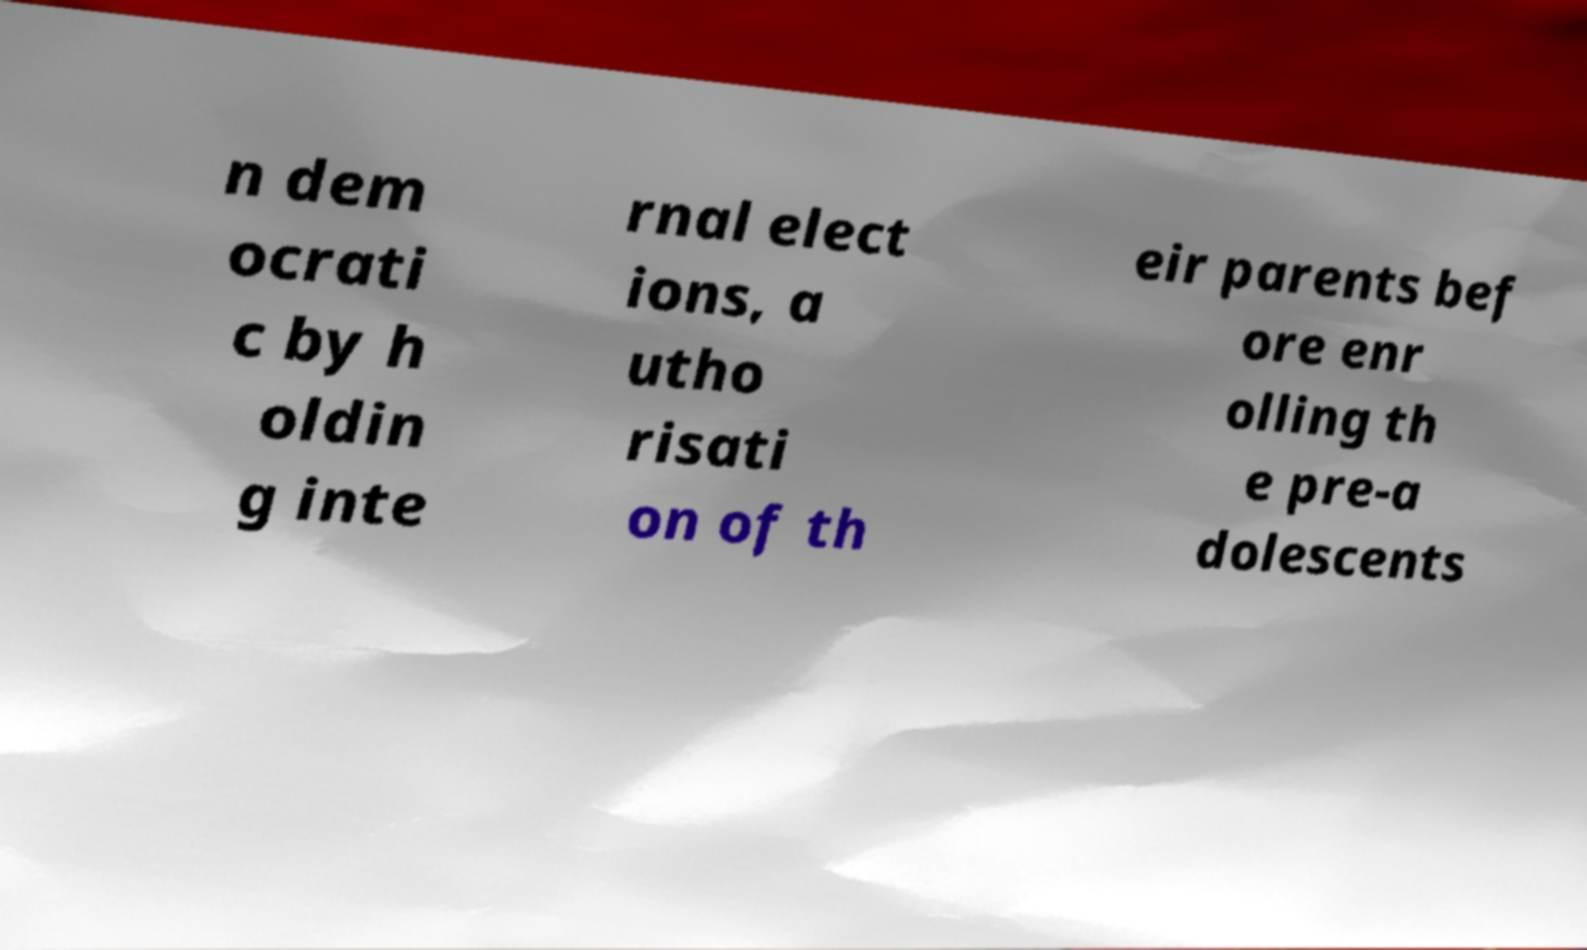Can you read and provide the text displayed in the image?This photo seems to have some interesting text. Can you extract and type it out for me? n dem ocrati c by h oldin g inte rnal elect ions, a utho risati on of th eir parents bef ore enr olling th e pre-a dolescents 